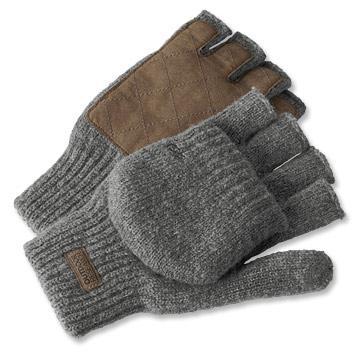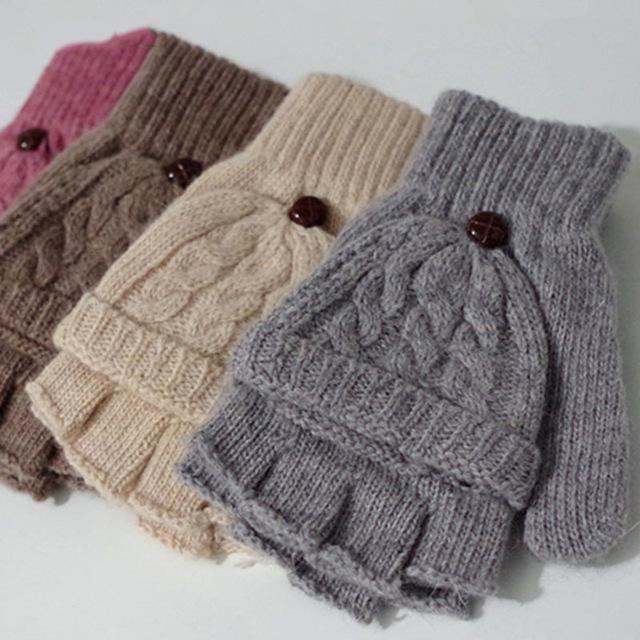The first image is the image on the left, the second image is the image on the right. Considering the images on both sides, is "There are a total of 2 hand models present wearing gloves." valid? Answer yes or no. No. The first image is the image on the left, the second image is the image on the right. Examine the images to the left and right. Is the description "There's a set of gloves that are not being worn." accurate? Answer yes or no. Yes. 